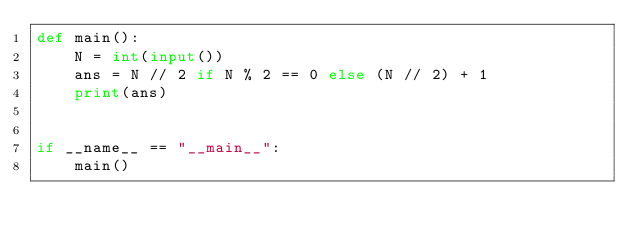<code> <loc_0><loc_0><loc_500><loc_500><_Python_>def main():
    N = int(input())
    ans = N // 2 if N % 2 == 0 else (N // 2) + 1
    print(ans)


if __name__ == "__main__":
    main()</code> 